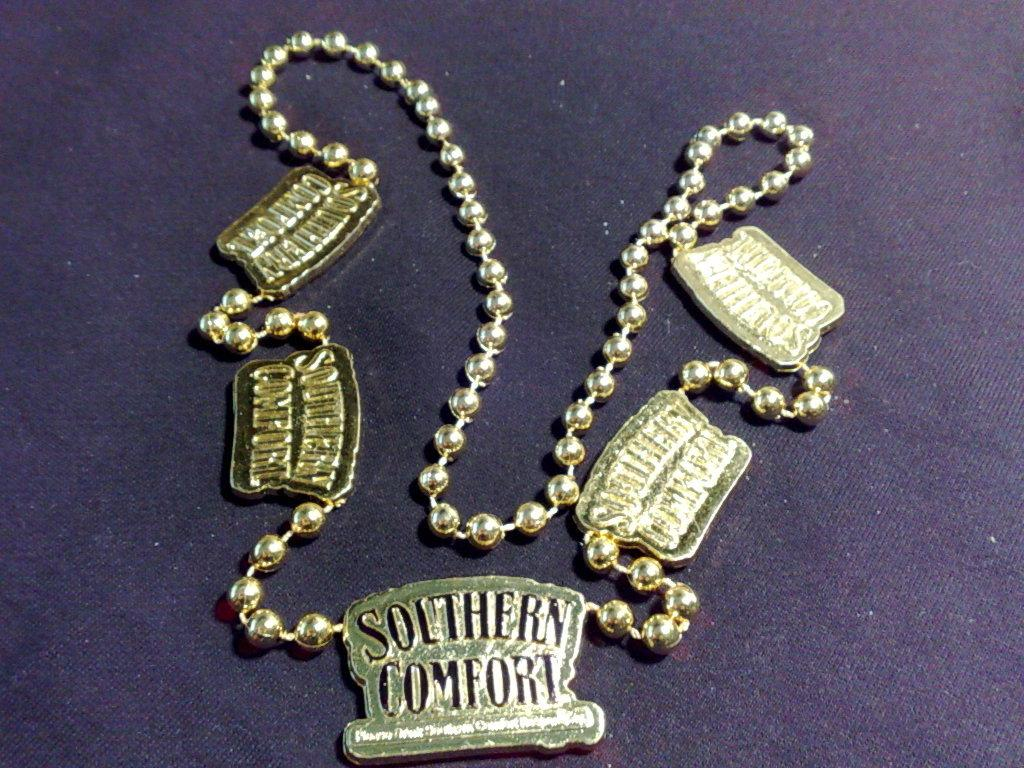<image>
Render a clear and concise summary of the photo. The chain has the saying Southern Comfort on it 